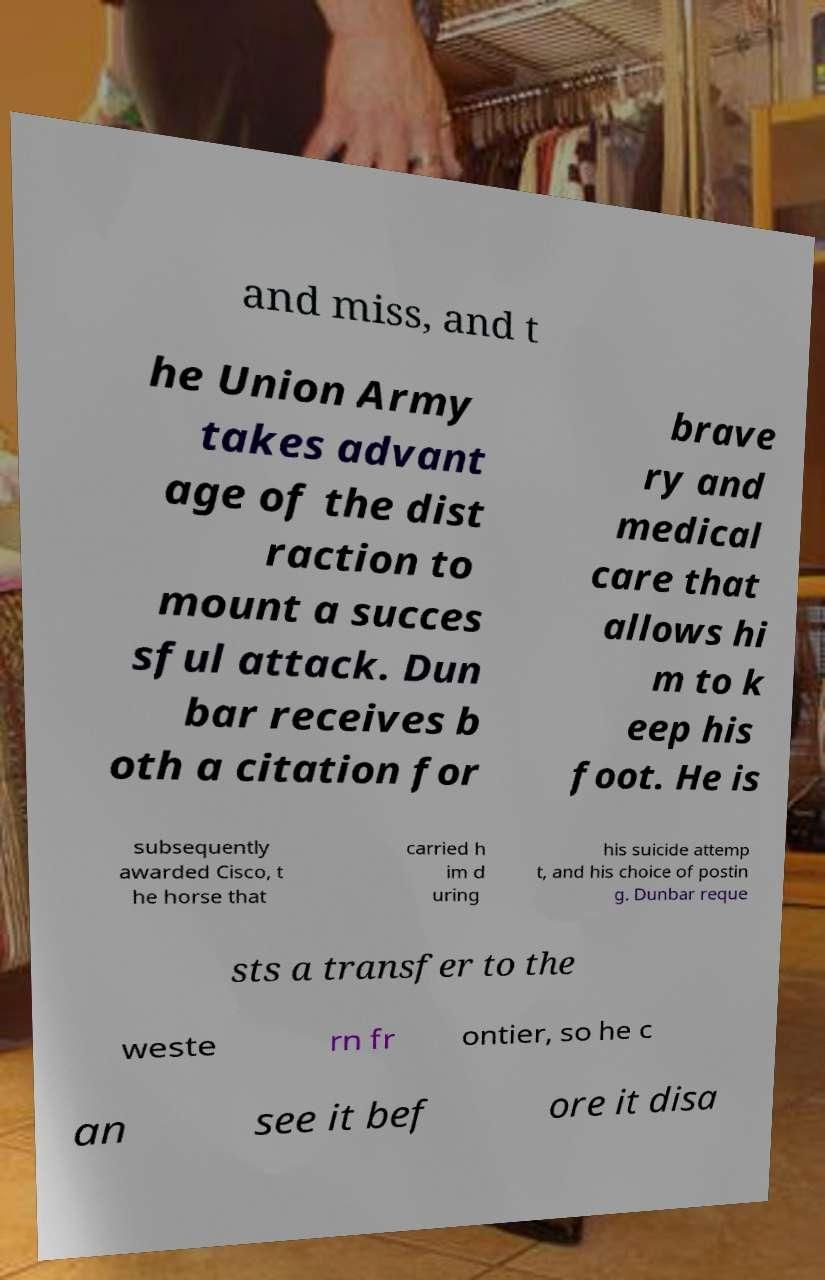What messages or text are displayed in this image? I need them in a readable, typed format. and miss, and t he Union Army takes advant age of the dist raction to mount a succes sful attack. Dun bar receives b oth a citation for brave ry and medical care that allows hi m to k eep his foot. He is subsequently awarded Cisco, t he horse that carried h im d uring his suicide attemp t, and his choice of postin g. Dunbar reque sts a transfer to the weste rn fr ontier, so he c an see it bef ore it disa 